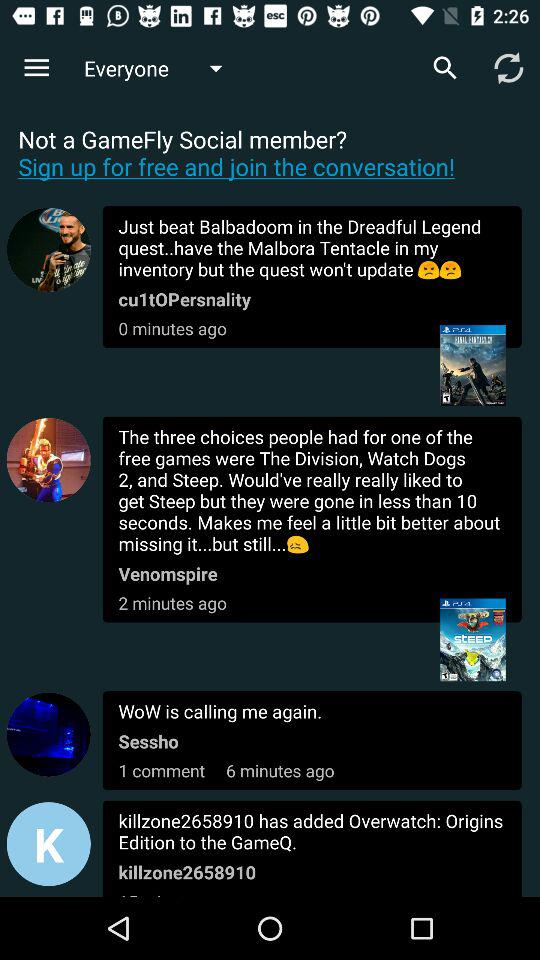Is signing up free or paid? Signing up is free. 